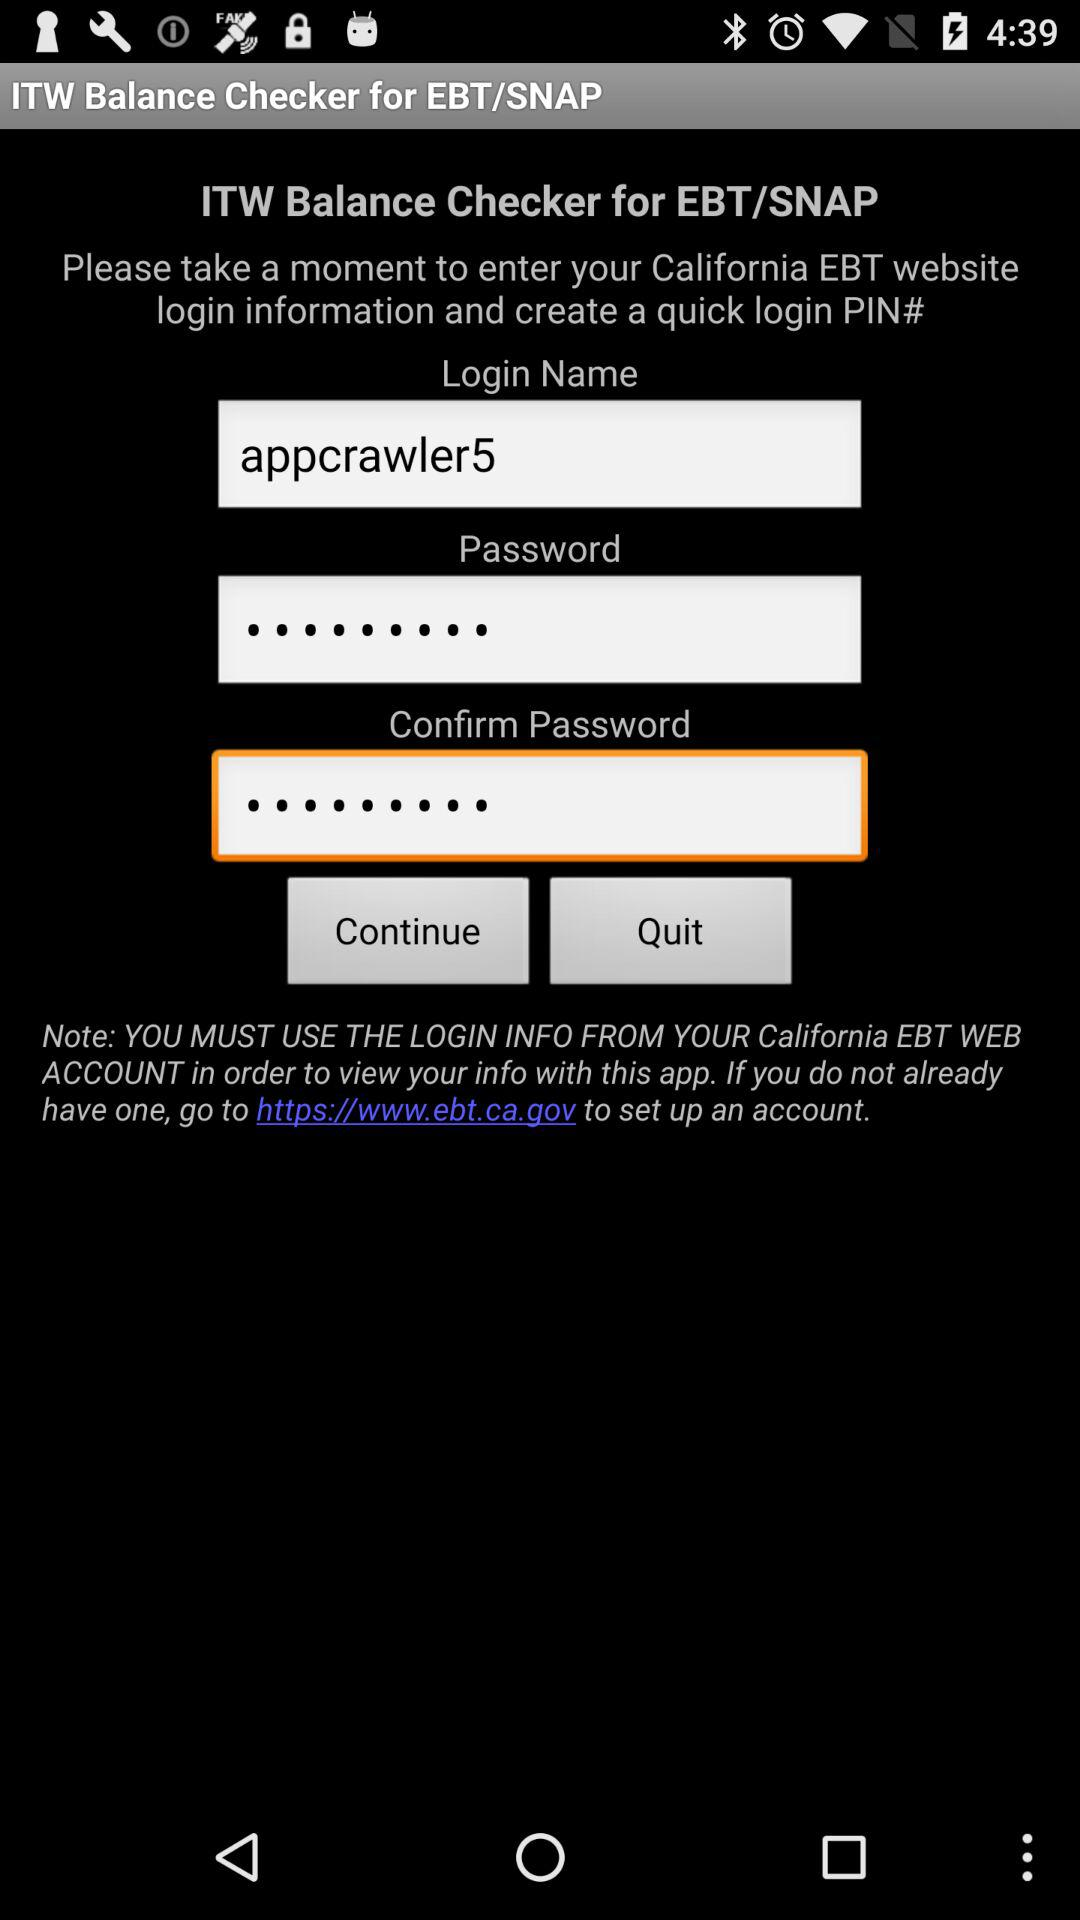What is the login name? The login name is "appcrawler5". 